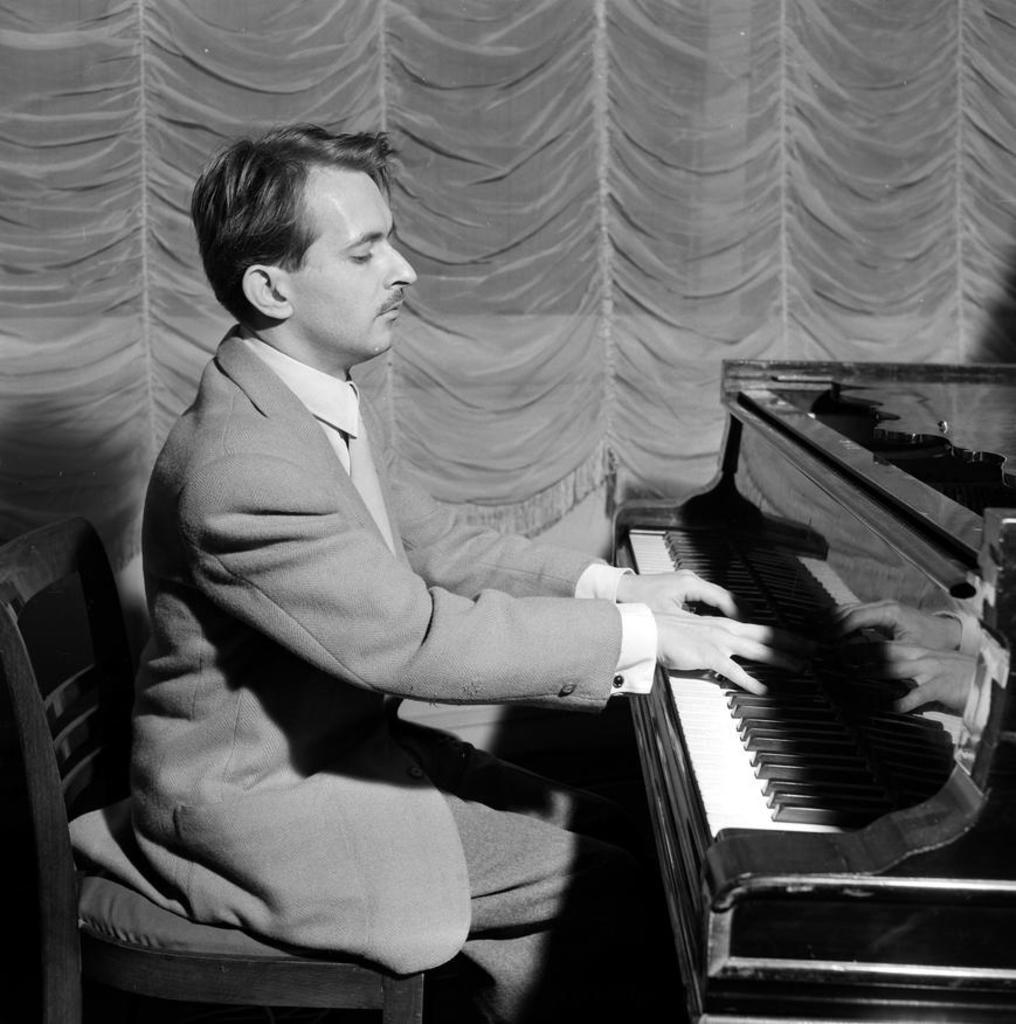Who is the person in the image? There is a man in the image. What is the man wearing? The man is wearing a blazer and a tie. What is the man doing in the image? The man is sitting on a chair and playing a piano. What can be seen in the background of the image? There are curtains in the background of the image. What type of mine is visible in the background of the image? There is no mine present in the image; it features a man playing a piano with curtains in the background. 